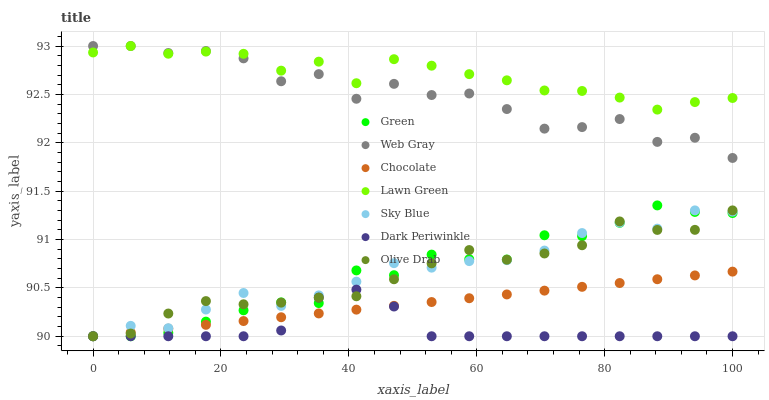Does Dark Periwinkle have the minimum area under the curve?
Answer yes or no. Yes. Does Lawn Green have the maximum area under the curve?
Answer yes or no. Yes. Does Web Gray have the minimum area under the curve?
Answer yes or no. No. Does Web Gray have the maximum area under the curve?
Answer yes or no. No. Is Chocolate the smoothest?
Answer yes or no. Yes. Is Web Gray the roughest?
Answer yes or no. Yes. Is Web Gray the smoothest?
Answer yes or no. No. Is Chocolate the roughest?
Answer yes or no. No. Does Chocolate have the lowest value?
Answer yes or no. Yes. Does Web Gray have the lowest value?
Answer yes or no. No. Does Web Gray have the highest value?
Answer yes or no. Yes. Does Chocolate have the highest value?
Answer yes or no. No. Is Dark Periwinkle less than Lawn Green?
Answer yes or no. Yes. Is Lawn Green greater than Olive Drab?
Answer yes or no. Yes. Does Dark Periwinkle intersect Chocolate?
Answer yes or no. Yes. Is Dark Periwinkle less than Chocolate?
Answer yes or no. No. Is Dark Periwinkle greater than Chocolate?
Answer yes or no. No. Does Dark Periwinkle intersect Lawn Green?
Answer yes or no. No. 